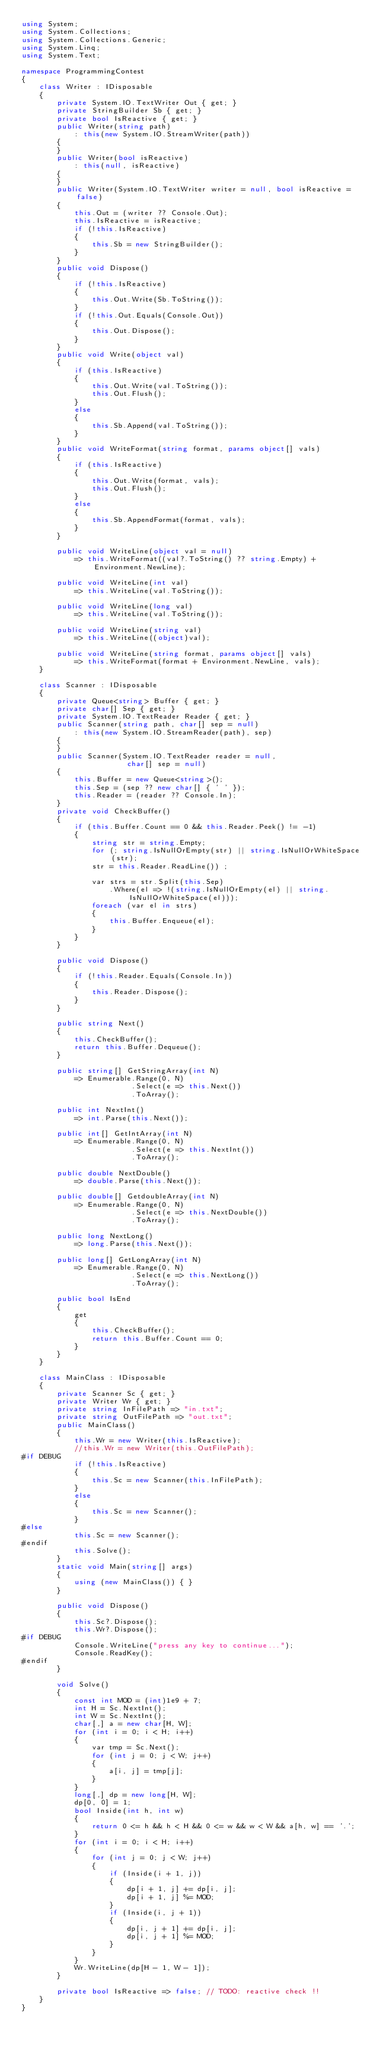Convert code to text. <code><loc_0><loc_0><loc_500><loc_500><_C#_>using System;
using System.Collections;
using System.Collections.Generic;
using System.Linq;
using System.Text;

namespace ProgrammingContest
{
    class Writer : IDisposable
    {
        private System.IO.TextWriter Out { get; }
        private StringBuilder Sb { get; }
        private bool IsReactive { get; }
        public Writer(string path)
            : this(new System.IO.StreamWriter(path))
        {
        }
        public Writer(bool isReactive)
            : this(null, isReactive)
        {
        }
        public Writer(System.IO.TextWriter writer = null, bool isReactive = false)
        {
            this.Out = (writer ?? Console.Out);
            this.IsReactive = isReactive;
            if (!this.IsReactive)
            {
                this.Sb = new StringBuilder();
            }
        }
        public void Dispose()
        {
            if (!this.IsReactive)
            {
                this.Out.Write(Sb.ToString());
            }
            if (!this.Out.Equals(Console.Out))
            {
                this.Out.Dispose();
            }
        }
        public void Write(object val)
        {
            if (this.IsReactive)
            {
                this.Out.Write(val.ToString());
                this.Out.Flush();
            }
            else
            {
                this.Sb.Append(val.ToString());
            }
        }
        public void WriteFormat(string format, params object[] vals)
        {
            if (this.IsReactive)
            {
                this.Out.Write(format, vals);
                this.Out.Flush();
            }
            else
            {
                this.Sb.AppendFormat(format, vals);
            }
        }

        public void WriteLine(object val = null)
            => this.WriteFormat((val?.ToString() ?? string.Empty) + Environment.NewLine);

        public void WriteLine(int val)
            => this.WriteLine(val.ToString());

        public void WriteLine(long val)
            => this.WriteLine(val.ToString());

        public void WriteLine(string val)
            => this.WriteLine((object)val);

        public void WriteLine(string format, params object[] vals)
            => this.WriteFormat(format + Environment.NewLine, vals);
    }

    class Scanner : IDisposable
    {
        private Queue<string> Buffer { get; }
        private char[] Sep { get; }
        private System.IO.TextReader Reader { get; }
        public Scanner(string path, char[] sep = null)
            : this(new System.IO.StreamReader(path), sep)
        {
        }
        public Scanner(System.IO.TextReader reader = null,
                        char[] sep = null)
        {
            this.Buffer = new Queue<string>();
            this.Sep = (sep ?? new char[] { ' ' });
            this.Reader = (reader ?? Console.In);
        }
        private void CheckBuffer()
        {
            if (this.Buffer.Count == 0 && this.Reader.Peek() != -1)
            {
                string str = string.Empty;
                for (; string.IsNullOrEmpty(str) || string.IsNullOrWhiteSpace(str);
                str = this.Reader.ReadLine()) ;

                var strs = str.Split(this.Sep)
                    .Where(el => !(string.IsNullOrEmpty(el) || string.IsNullOrWhiteSpace(el)));
                foreach (var el in strs)
                {
                    this.Buffer.Enqueue(el);
                }
            }
        }

        public void Dispose()
        {
            if (!this.Reader.Equals(Console.In))
            {
                this.Reader.Dispose();
            }
        }

        public string Next()
        {
            this.CheckBuffer();
            return this.Buffer.Dequeue();
        }

        public string[] GetStringArray(int N)
            => Enumerable.Range(0, N)
                         .Select(e => this.Next())
                         .ToArray();

        public int NextInt()
            => int.Parse(this.Next());

        public int[] GetIntArray(int N)
            => Enumerable.Range(0, N)
                         .Select(e => this.NextInt())
                         .ToArray();

        public double NextDouble()
            => double.Parse(this.Next());

        public double[] GetdoubleArray(int N)
            => Enumerable.Range(0, N)
                         .Select(e => this.NextDouble())
                         .ToArray();

        public long NextLong()
            => long.Parse(this.Next());

        public long[] GetLongArray(int N)
            => Enumerable.Range(0, N)
                         .Select(e => this.NextLong())
                         .ToArray();

        public bool IsEnd
        {
            get
            {
                this.CheckBuffer();
                return this.Buffer.Count == 0;
            }
        }
    }

    class MainClass : IDisposable
    {
        private Scanner Sc { get; }
        private Writer Wr { get; }
        private string InFilePath => "in.txt";
        private string OutFilePath => "out.txt";
        public MainClass()
        {
            this.Wr = new Writer(this.IsReactive);
            //this.Wr = new Writer(this.OutFilePath);
#if DEBUG
            if (!this.IsReactive)
            {
                this.Sc = new Scanner(this.InFilePath);
            }
            else
            {
                this.Sc = new Scanner();
            }
#else
            this.Sc = new Scanner();
#endif
            this.Solve();
        }
        static void Main(string[] args)
        {
            using (new MainClass()) { }
        }

        public void Dispose()
        {
            this.Sc?.Dispose();
            this.Wr?.Dispose();
#if DEBUG
            Console.WriteLine("press any key to continue...");
            Console.ReadKey();
#endif
        }
        
        void Solve()
        {
            const int MOD = (int)1e9 + 7;
            int H = Sc.NextInt();
            int W = Sc.NextInt();
            char[,] a = new char[H, W];
            for (int i = 0; i < H; i++)
            {
                var tmp = Sc.Next();
                for (int j = 0; j < W; j++)
                {
                    a[i, j] = tmp[j];
                }
            }
            long[,] dp = new long[H, W];
            dp[0, 0] = 1;
            bool Inside(int h, int w)
            {
                return 0 <= h && h < H && 0 <= w && w < W && a[h, w] == '.';
            }
            for (int i = 0; i < H; i++)
            {
                for (int j = 0; j < W; j++)
                {
                    if (Inside(i + 1, j))
                    {
                        dp[i + 1, j] += dp[i, j];
                        dp[i + 1, j] %= MOD;
                    }
                    if (Inside(i, j + 1))
                    {
                        dp[i, j + 1] += dp[i, j];
                        dp[i, j + 1] %= MOD;
                    }
                }
            }
            Wr.WriteLine(dp[H - 1, W - 1]);
        }

        private bool IsReactive => false; // TODO: reactive check !!
    }
}
</code> 